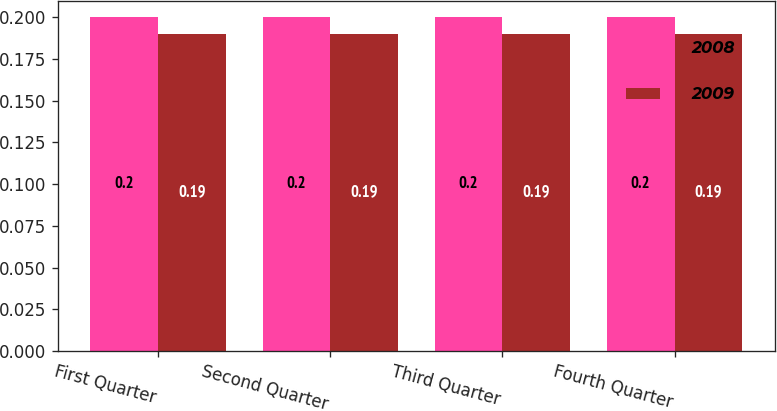Convert chart. <chart><loc_0><loc_0><loc_500><loc_500><stacked_bar_chart><ecel><fcel>First Quarter<fcel>Second Quarter<fcel>Third Quarter<fcel>Fourth Quarter<nl><fcel>2008<fcel>0.2<fcel>0.2<fcel>0.2<fcel>0.2<nl><fcel>2009<fcel>0.19<fcel>0.19<fcel>0.19<fcel>0.19<nl></chart> 